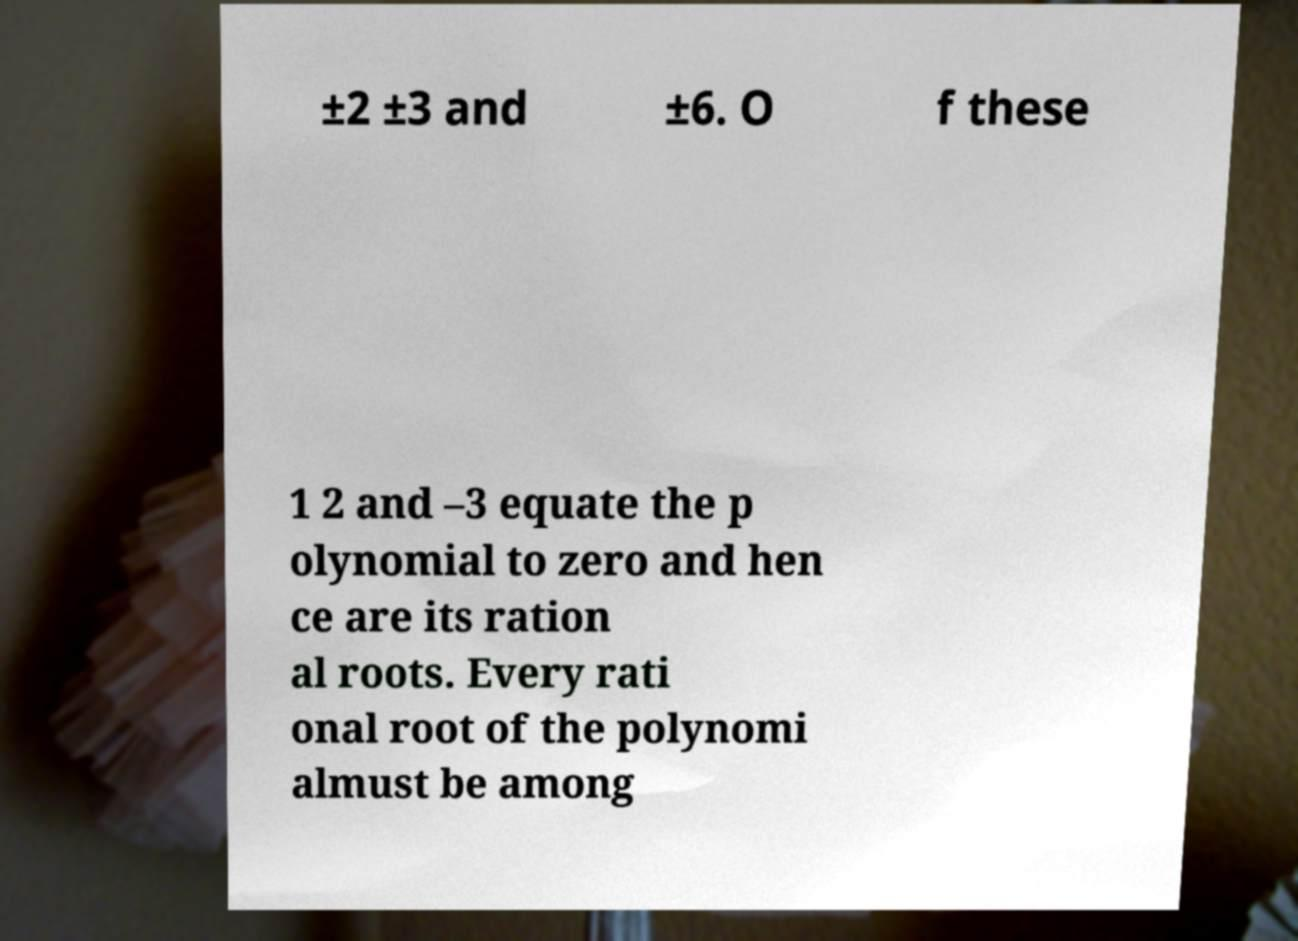Could you assist in decoding the text presented in this image and type it out clearly? ±2 ±3 and ±6. O f these 1 2 and –3 equate the p olynomial to zero and hen ce are its ration al roots. Every rati onal root of the polynomi almust be among 